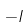<formula> <loc_0><loc_0><loc_500><loc_500>- I</formula> 